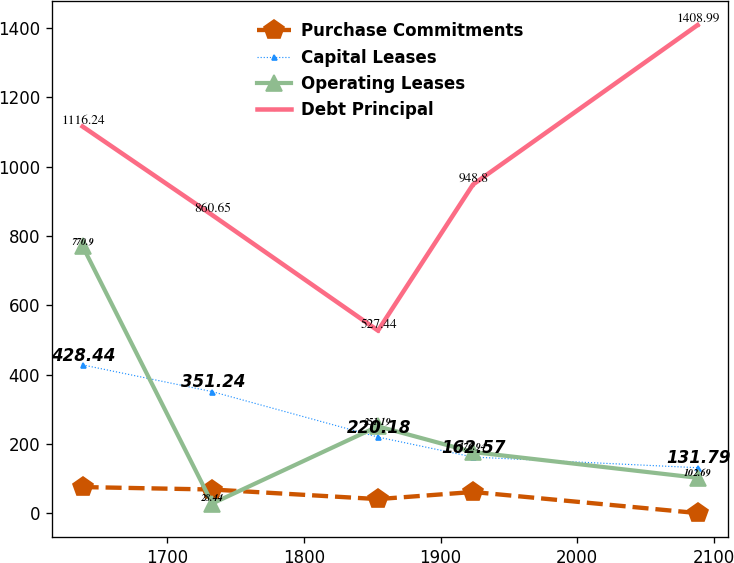<chart> <loc_0><loc_0><loc_500><loc_500><line_chart><ecel><fcel>Purchase Commitments<fcel>Capital Leases<fcel>Operating Leases<fcel>Debt Principal<nl><fcel>1638.12<fcel>76<fcel>428.44<fcel>770.9<fcel>1116.24<nl><fcel>1733<fcel>68.89<fcel>351.24<fcel>28.44<fcel>860.65<nl><fcel>1854.25<fcel>41.24<fcel>220.18<fcel>251.19<fcel>527.44<nl><fcel>1923.78<fcel>61.78<fcel>162.57<fcel>176.94<fcel>948.8<nl><fcel>2088.12<fcel>0.9<fcel>131.79<fcel>102.69<fcel>1408.99<nl></chart> 